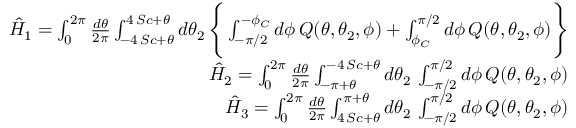<formula> <loc_0><loc_0><loc_500><loc_500>\begin{array} { r l r } & { \hat { H } _ { 1 } = \int _ { 0 } ^ { 2 \pi } { \frac { d \theta } { 2 \pi } } \int _ { - 4 \, S c + \theta } ^ { 4 \, S c + \theta } d \theta _ { 2 } \, \left \{ \int _ { - \pi / 2 } ^ { - \phi _ { C } } d \phi \, Q ( \theta , \theta _ { 2 } , \phi ) + \int _ { \phi _ { C } } ^ { \pi / 2 } d \phi \, Q ( \theta , \theta _ { 2 } , \phi ) \right \} } \\ & { \hat { H } _ { 2 } = \int _ { 0 } ^ { 2 \pi } { \frac { d \theta } { 2 \pi } } \int _ { - \pi + \theta } ^ { - 4 \, S c + \theta } d \theta _ { 2 } \, \int _ { - \pi / 2 } ^ { \pi / 2 } d \phi \, Q ( \theta , \theta _ { 2 } , \phi ) } \\ & { \hat { H } _ { 3 } = \int _ { 0 } ^ { 2 \pi } { \frac { d \theta } { 2 \pi } } \int _ { 4 \, S c + \theta } ^ { \pi + \theta } d \theta _ { 2 } \, \int _ { - \pi / 2 } ^ { \pi / 2 } d \phi \, Q ( \theta , \theta _ { 2 } , \phi ) } \end{array}</formula> 